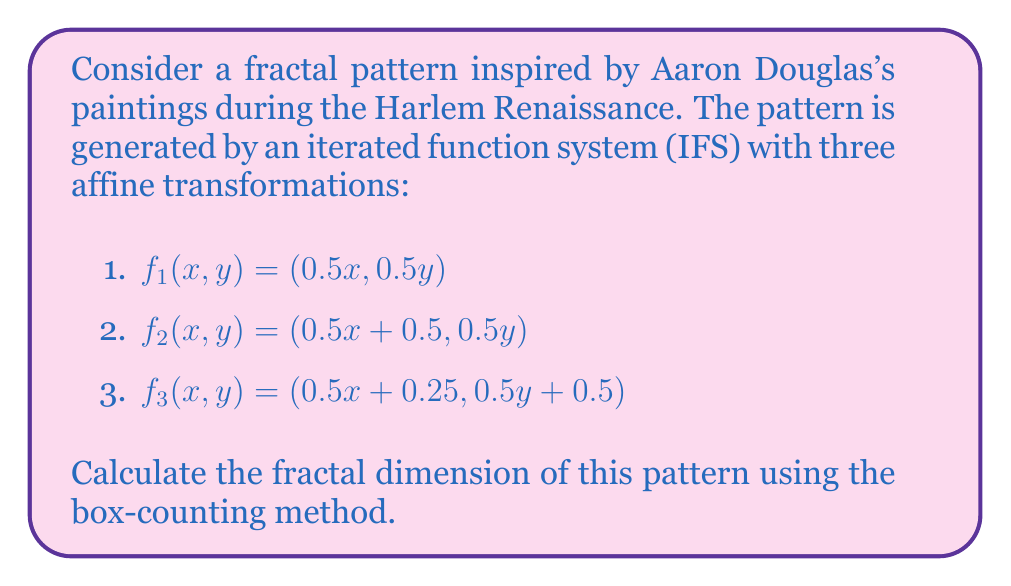Teach me how to tackle this problem. To calculate the fractal dimension using the box-counting method, we follow these steps:

1) First, we need to understand that the fractal dimension $D$ is given by:

   $$D = \lim_{ε→0} \frac{\log N(ε)}{\log(1/ε)}$$

   where $N(ε)$ is the number of boxes of size $ε$ needed to cover the fractal.

2) For an IFS fractal, we can calculate $D$ directly using the contraction factors of the transformations. The formula is:

   $$\sum_{i=1}^{n} r_i^D = 1$$

   where $r_i$ are the contraction factors of each transformation.

3) In our case, all transformations have the same contraction factor of 0.5. There are 3 transformations. So our equation becomes:

   $$3 \cdot (0.5)^D = 1$$

4) Solving for $D$:

   $$3 = (2)^D$$

   $$\log_2 3 = D$$

5) Calculate the value:

   $$D = \frac{\log 3}{\log 2} \approx 1.5850$$

This fractal dimension between 1 and 2 indicates a complex, self-similar structure that's more intricate than a simple line (dimension 1) but doesn't quite fill a 2D plane.
Answer: $\frac{\log 3}{\log 2} \approx 1.5850$ 